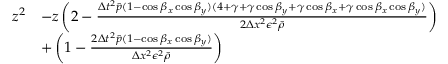<formula> <loc_0><loc_0><loc_500><loc_500>\begin{array} { r l } { z ^ { 2 } } & { - z \left ( 2 - \frac { \Delta t ^ { 2 } \bar { p } ( 1 - \cos \beta _ { x } \cos \beta _ { y } ) ( 4 + \gamma + \gamma \cos \beta _ { y } + \gamma \cos \beta _ { x } + \gamma \cos \beta _ { x } \cos \beta _ { y } ) } { 2 \Delta x ^ { 2 } \epsilon ^ { 2 } \bar { \rho } } \right ) } \\ & { + \left ( 1 - \frac { 2 \Delta t ^ { 2 } \bar { p } ( 1 - \cos \beta _ { x } \cos \beta _ { y } ) } { \Delta x ^ { 2 } \epsilon ^ { 2 } \bar { \rho } } \right ) } \end{array}</formula> 